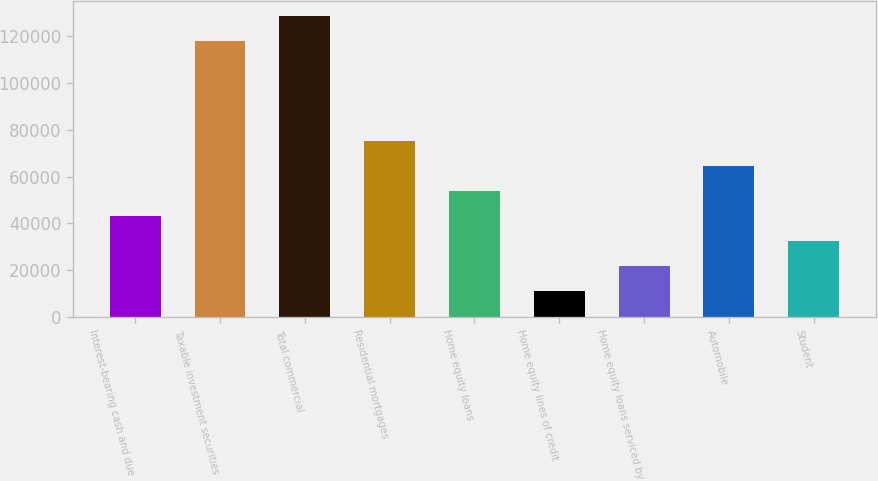<chart> <loc_0><loc_0><loc_500><loc_500><bar_chart><fcel>Interest-bearing cash and due<fcel>Taxable investment securities<fcel>Total commercial<fcel>Residential mortgages<fcel>Home equity loans<fcel>Home equity lines of credit<fcel>Home equity loans serviced by<fcel>Automobile<fcel>Student<nl><fcel>43094.8<fcel>117825<fcel>128500<fcel>75121.9<fcel>53770.5<fcel>11067.7<fcel>21743.4<fcel>64446.2<fcel>32419.1<nl></chart> 